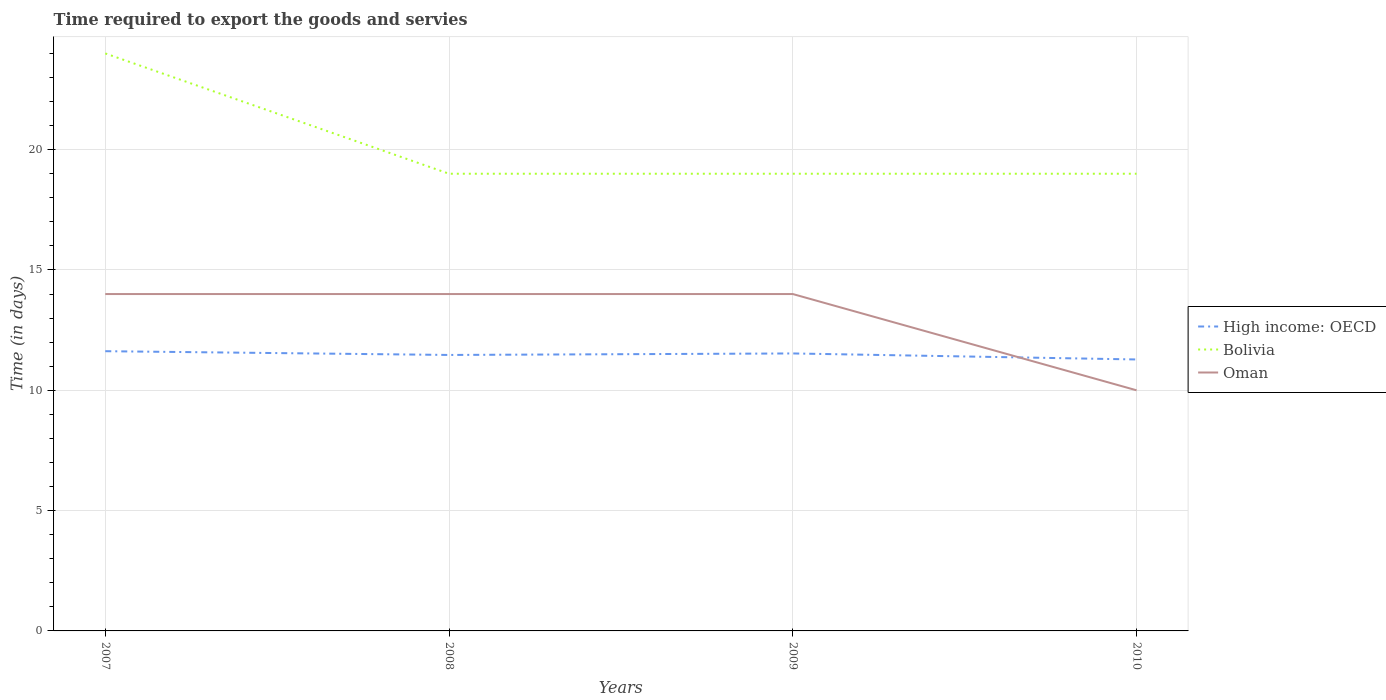How many different coloured lines are there?
Make the answer very short. 3. Does the line corresponding to High income: OECD intersect with the line corresponding to Bolivia?
Keep it short and to the point. No. Is the number of lines equal to the number of legend labels?
Ensure brevity in your answer.  Yes. Across all years, what is the maximum number of days required to export the goods and services in Oman?
Offer a very short reply. 10. In which year was the number of days required to export the goods and services in Bolivia maximum?
Offer a very short reply. 2008. What is the total number of days required to export the goods and services in High income: OECD in the graph?
Give a very brief answer. 0.19. What is the difference between the highest and the second highest number of days required to export the goods and services in Bolivia?
Make the answer very short. 5. What is the difference between the highest and the lowest number of days required to export the goods and services in Oman?
Make the answer very short. 3. Does the graph contain any zero values?
Provide a short and direct response. No. How are the legend labels stacked?
Give a very brief answer. Vertical. What is the title of the graph?
Ensure brevity in your answer.  Time required to export the goods and servies. What is the label or title of the Y-axis?
Your answer should be very brief. Time (in days). What is the Time (in days) of High income: OECD in 2007?
Provide a succinct answer. 11.62. What is the Time (in days) in Oman in 2007?
Your answer should be very brief. 14. What is the Time (in days) of High income: OECD in 2008?
Your answer should be very brief. 11.47. What is the Time (in days) of Bolivia in 2008?
Keep it short and to the point. 19. What is the Time (in days) in Oman in 2008?
Your response must be concise. 14. What is the Time (in days) in High income: OECD in 2009?
Provide a short and direct response. 11.53. What is the Time (in days) of Oman in 2009?
Your answer should be very brief. 14. What is the Time (in days) in High income: OECD in 2010?
Your answer should be compact. 11.28. What is the Time (in days) in Oman in 2010?
Your answer should be very brief. 10. Across all years, what is the maximum Time (in days) in High income: OECD?
Your response must be concise. 11.62. Across all years, what is the maximum Time (in days) in Bolivia?
Provide a succinct answer. 24. Across all years, what is the minimum Time (in days) in High income: OECD?
Make the answer very short. 11.28. Across all years, what is the minimum Time (in days) of Oman?
Your response must be concise. 10. What is the total Time (in days) in High income: OECD in the graph?
Provide a succinct answer. 45.91. What is the total Time (in days) of Bolivia in the graph?
Give a very brief answer. 81. What is the total Time (in days) in Oman in the graph?
Your response must be concise. 52. What is the difference between the Time (in days) of High income: OECD in 2007 and that in 2008?
Your answer should be compact. 0.16. What is the difference between the Time (in days) in Oman in 2007 and that in 2008?
Offer a terse response. 0. What is the difference between the Time (in days) in High income: OECD in 2007 and that in 2009?
Provide a short and direct response. 0.09. What is the difference between the Time (in days) of Bolivia in 2007 and that in 2009?
Ensure brevity in your answer.  5. What is the difference between the Time (in days) in High income: OECD in 2007 and that in 2010?
Keep it short and to the point. 0.34. What is the difference between the Time (in days) in Bolivia in 2007 and that in 2010?
Make the answer very short. 5. What is the difference between the Time (in days) in Oman in 2007 and that in 2010?
Keep it short and to the point. 4. What is the difference between the Time (in days) of High income: OECD in 2008 and that in 2009?
Your answer should be very brief. -0.06. What is the difference between the Time (in days) in Bolivia in 2008 and that in 2009?
Ensure brevity in your answer.  0. What is the difference between the Time (in days) in Oman in 2008 and that in 2009?
Provide a short and direct response. 0. What is the difference between the Time (in days) of High income: OECD in 2008 and that in 2010?
Offer a very short reply. 0.19. What is the difference between the Time (in days) of Bolivia in 2008 and that in 2010?
Make the answer very short. 0. What is the difference between the Time (in days) of High income: OECD in 2009 and that in 2010?
Keep it short and to the point. 0.25. What is the difference between the Time (in days) in Bolivia in 2009 and that in 2010?
Give a very brief answer. 0. What is the difference between the Time (in days) in Oman in 2009 and that in 2010?
Provide a short and direct response. 4. What is the difference between the Time (in days) of High income: OECD in 2007 and the Time (in days) of Bolivia in 2008?
Your answer should be very brief. -7.38. What is the difference between the Time (in days) in High income: OECD in 2007 and the Time (in days) in Oman in 2008?
Provide a short and direct response. -2.38. What is the difference between the Time (in days) of Bolivia in 2007 and the Time (in days) of Oman in 2008?
Provide a succinct answer. 10. What is the difference between the Time (in days) of High income: OECD in 2007 and the Time (in days) of Bolivia in 2009?
Your response must be concise. -7.38. What is the difference between the Time (in days) in High income: OECD in 2007 and the Time (in days) in Oman in 2009?
Your answer should be compact. -2.38. What is the difference between the Time (in days) of High income: OECD in 2007 and the Time (in days) of Bolivia in 2010?
Your answer should be compact. -7.38. What is the difference between the Time (in days) in High income: OECD in 2007 and the Time (in days) in Oman in 2010?
Give a very brief answer. 1.62. What is the difference between the Time (in days) of Bolivia in 2007 and the Time (in days) of Oman in 2010?
Your response must be concise. 14. What is the difference between the Time (in days) in High income: OECD in 2008 and the Time (in days) in Bolivia in 2009?
Ensure brevity in your answer.  -7.53. What is the difference between the Time (in days) in High income: OECD in 2008 and the Time (in days) in Oman in 2009?
Offer a very short reply. -2.53. What is the difference between the Time (in days) of Bolivia in 2008 and the Time (in days) of Oman in 2009?
Your response must be concise. 5. What is the difference between the Time (in days) in High income: OECD in 2008 and the Time (in days) in Bolivia in 2010?
Give a very brief answer. -7.53. What is the difference between the Time (in days) in High income: OECD in 2008 and the Time (in days) in Oman in 2010?
Offer a terse response. 1.47. What is the difference between the Time (in days) in High income: OECD in 2009 and the Time (in days) in Bolivia in 2010?
Keep it short and to the point. -7.47. What is the difference between the Time (in days) in High income: OECD in 2009 and the Time (in days) in Oman in 2010?
Provide a succinct answer. 1.53. What is the difference between the Time (in days) of Bolivia in 2009 and the Time (in days) of Oman in 2010?
Give a very brief answer. 9. What is the average Time (in days) in High income: OECD per year?
Ensure brevity in your answer.  11.48. What is the average Time (in days) in Bolivia per year?
Provide a succinct answer. 20.25. What is the average Time (in days) of Oman per year?
Keep it short and to the point. 13. In the year 2007, what is the difference between the Time (in days) in High income: OECD and Time (in days) in Bolivia?
Ensure brevity in your answer.  -12.38. In the year 2007, what is the difference between the Time (in days) of High income: OECD and Time (in days) of Oman?
Your answer should be compact. -2.38. In the year 2008, what is the difference between the Time (in days) in High income: OECD and Time (in days) in Bolivia?
Offer a very short reply. -7.53. In the year 2008, what is the difference between the Time (in days) in High income: OECD and Time (in days) in Oman?
Make the answer very short. -2.53. In the year 2009, what is the difference between the Time (in days) in High income: OECD and Time (in days) in Bolivia?
Your answer should be very brief. -7.47. In the year 2009, what is the difference between the Time (in days) of High income: OECD and Time (in days) of Oman?
Provide a succinct answer. -2.47. In the year 2009, what is the difference between the Time (in days) of Bolivia and Time (in days) of Oman?
Provide a succinct answer. 5. In the year 2010, what is the difference between the Time (in days) of High income: OECD and Time (in days) of Bolivia?
Offer a very short reply. -7.72. In the year 2010, what is the difference between the Time (in days) of High income: OECD and Time (in days) of Oman?
Give a very brief answer. 1.28. What is the ratio of the Time (in days) of High income: OECD in 2007 to that in 2008?
Make the answer very short. 1.01. What is the ratio of the Time (in days) in Bolivia in 2007 to that in 2008?
Ensure brevity in your answer.  1.26. What is the ratio of the Time (in days) in Bolivia in 2007 to that in 2009?
Ensure brevity in your answer.  1.26. What is the ratio of the Time (in days) of High income: OECD in 2007 to that in 2010?
Your response must be concise. 1.03. What is the ratio of the Time (in days) of Bolivia in 2007 to that in 2010?
Your answer should be very brief. 1.26. What is the ratio of the Time (in days) of Bolivia in 2008 to that in 2009?
Your answer should be compact. 1. What is the ratio of the Time (in days) in Oman in 2008 to that in 2009?
Make the answer very short. 1. What is the ratio of the Time (in days) in High income: OECD in 2008 to that in 2010?
Offer a very short reply. 1.02. What is the ratio of the Time (in days) in High income: OECD in 2009 to that in 2010?
Give a very brief answer. 1.02. What is the ratio of the Time (in days) of Bolivia in 2009 to that in 2010?
Make the answer very short. 1. What is the ratio of the Time (in days) in Oman in 2009 to that in 2010?
Give a very brief answer. 1.4. What is the difference between the highest and the second highest Time (in days) of High income: OECD?
Your answer should be compact. 0.09. What is the difference between the highest and the second highest Time (in days) in Bolivia?
Provide a succinct answer. 5. What is the difference between the highest and the second highest Time (in days) of Oman?
Make the answer very short. 0. What is the difference between the highest and the lowest Time (in days) in High income: OECD?
Offer a terse response. 0.34. What is the difference between the highest and the lowest Time (in days) of Bolivia?
Keep it short and to the point. 5. What is the difference between the highest and the lowest Time (in days) in Oman?
Your answer should be very brief. 4. 